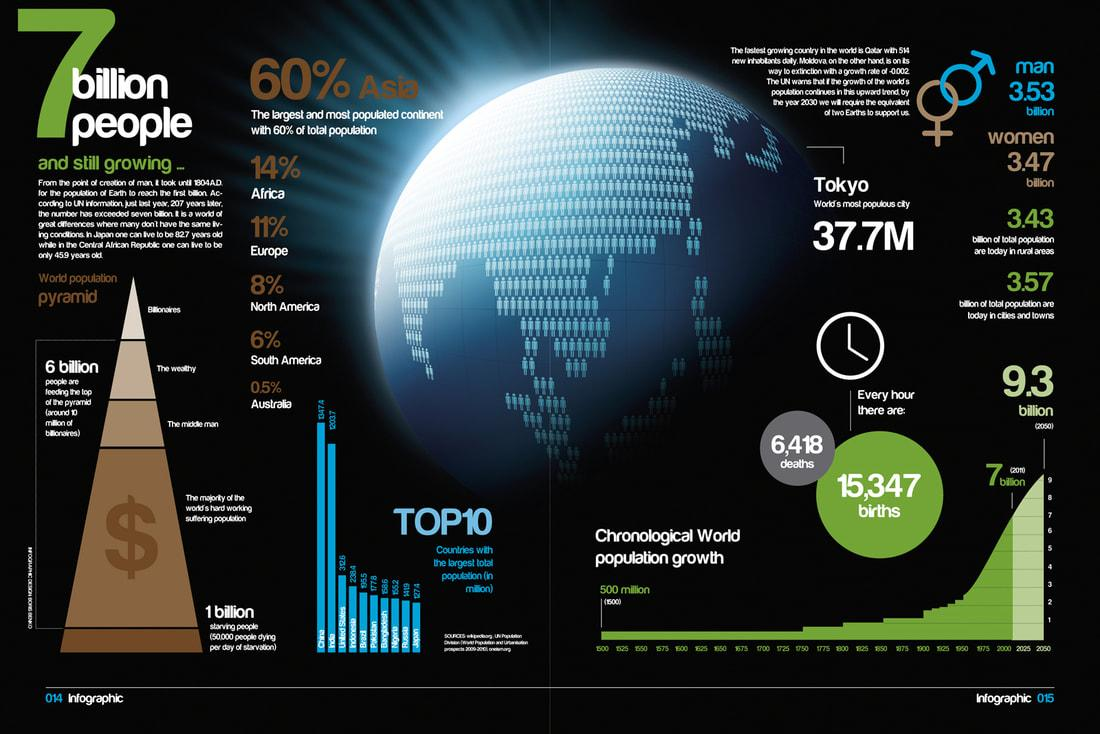Identify some key points in this picture. Taken together, approximately 25% of the population resides in Africa and Europe. There is a difference between the number of births and deaths in every hour, with 8,929 being the total number of births and deaths occurring in one hour. The population in rural, city, and town areas is approximately 7 billion. According to the given information, the percentage of the population in North America and South America taken together is 14%. 